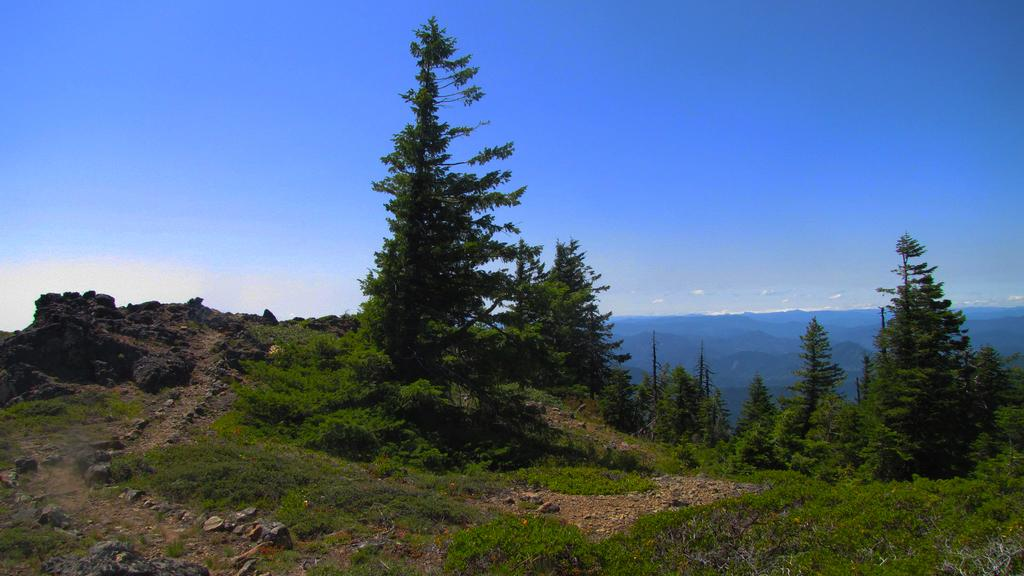What type of vegetation can be seen in the image? There are trees, plants, and grass visible in the image. What is present on the ground in the image? There are stones on the ground in the image. What can be seen in the background of the image? There are hills and clouds visible in the background of the image. What type of pencil can be seen in the image? There is no pencil present in the image. How does the tail of the animal in the image move? There is no animal with a tail present in the image. 